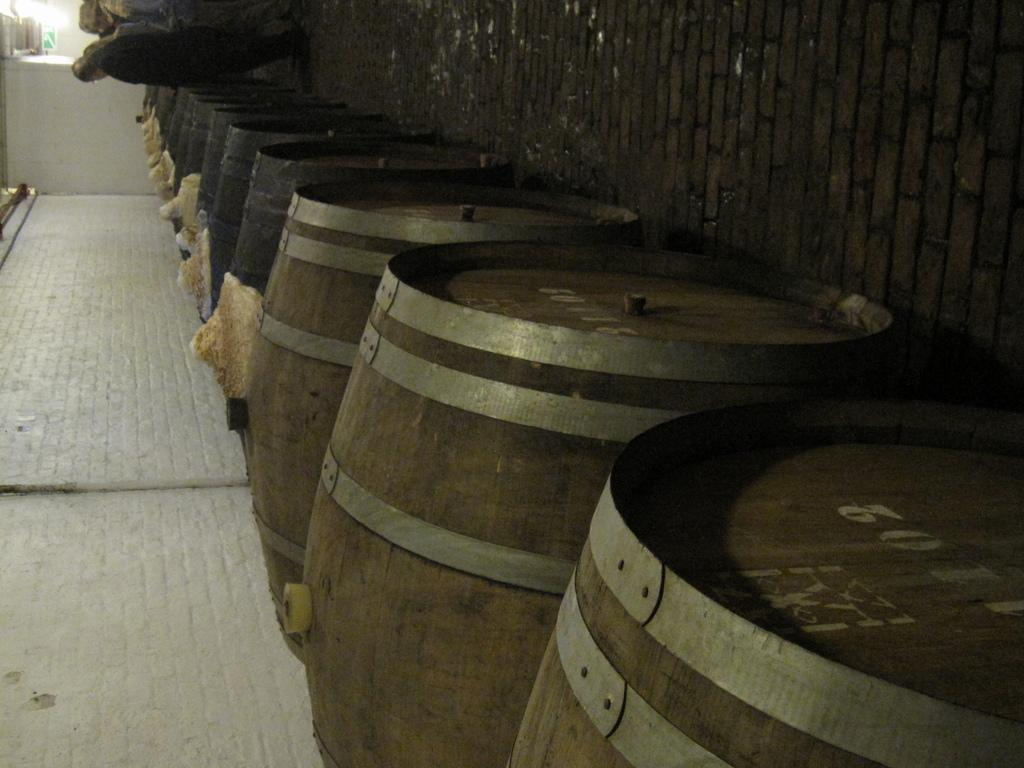<image>
Share a concise interpretation of the image provided. Several wooden barrels, with the one closest to the picture taker reading 3011. 